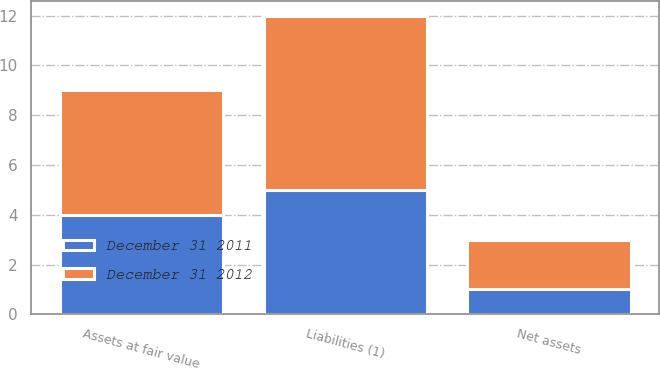<chart> <loc_0><loc_0><loc_500><loc_500><stacked_bar_chart><ecel><fcel>Assets at fair value<fcel>Liabilities (1)<fcel>Net assets<nl><fcel>December 31 2011<fcel>4<fcel>5<fcel>1<nl><fcel>December 31 2012<fcel>5<fcel>7<fcel>2<nl></chart> 